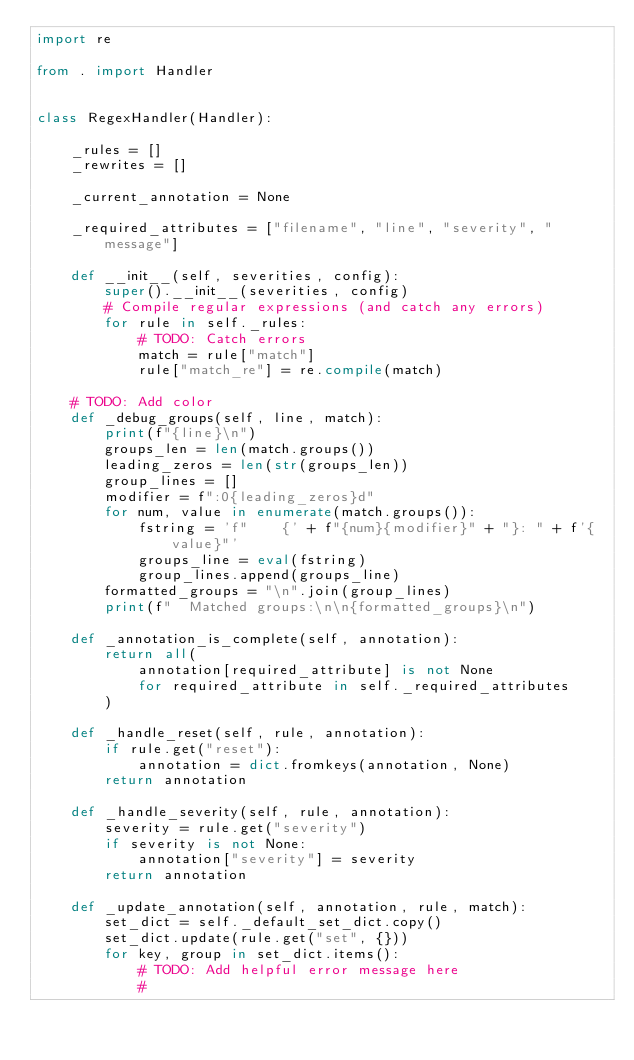Convert code to text. <code><loc_0><loc_0><loc_500><loc_500><_Python_>import re

from . import Handler


class RegexHandler(Handler):

    _rules = []
    _rewrites = []

    _current_annotation = None

    _required_attributes = ["filename", "line", "severity", "message"]

    def __init__(self, severities, config):
        super().__init__(severities, config)
        # Compile regular expressions (and catch any errors)
        for rule in self._rules:
            # TODO: Catch errors
            match = rule["match"]
            rule["match_re"] = re.compile(match)

    # TODO: Add color
    def _debug_groups(self, line, match):
        print(f"{line}\n")
        groups_len = len(match.groups())
        leading_zeros = len(str(groups_len))
        group_lines = []
        modifier = f":0{leading_zeros}d"
        for num, value in enumerate(match.groups()):
            fstring = 'f"    {' + f"{num}{modifier}" + "}: " + f'{value}"'
            groups_line = eval(fstring)
            group_lines.append(groups_line)
        formatted_groups = "\n".join(group_lines)
        print(f"  Matched groups:\n\n{formatted_groups}\n")

    def _annotation_is_complete(self, annotation):
        return all(
            annotation[required_attribute] is not None
            for required_attribute in self._required_attributes
        )

    def _handle_reset(self, rule, annotation):
        if rule.get("reset"):
            annotation = dict.fromkeys(annotation, None)
        return annotation

    def _handle_severity(self, rule, annotation):
        severity = rule.get("severity")
        if severity is not None:
            annotation["severity"] = severity
        return annotation

    def _update_annotation(self, annotation, rule, match):
        set_dict = self._default_set_dict.copy()
        set_dict.update(rule.get("set", {}))
        for key, group in set_dict.items():
            # TODO: Add helpful error message here
            #</code> 